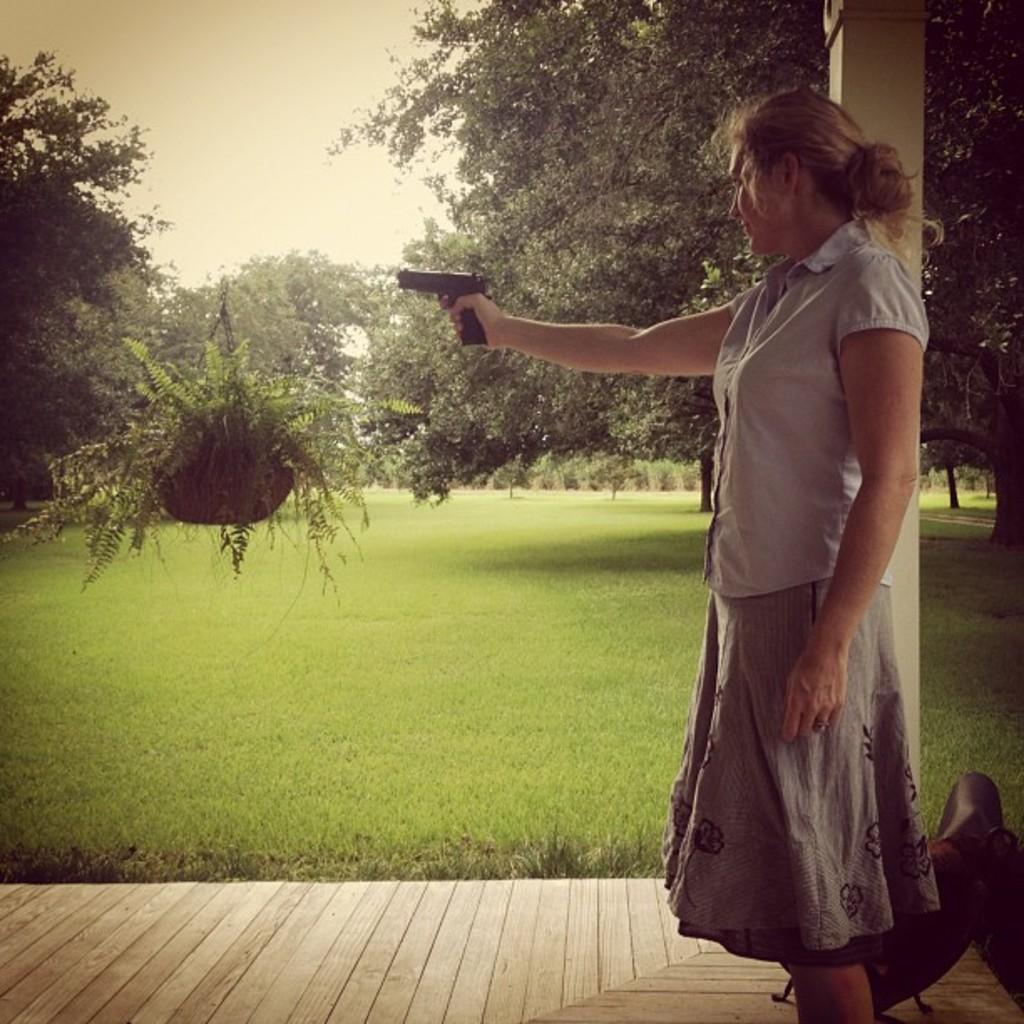Please provide a concise description of this image. In the image there is a woman standing on a wooden surface, she is holding a gun and around the woman there is a garden and many trees. 